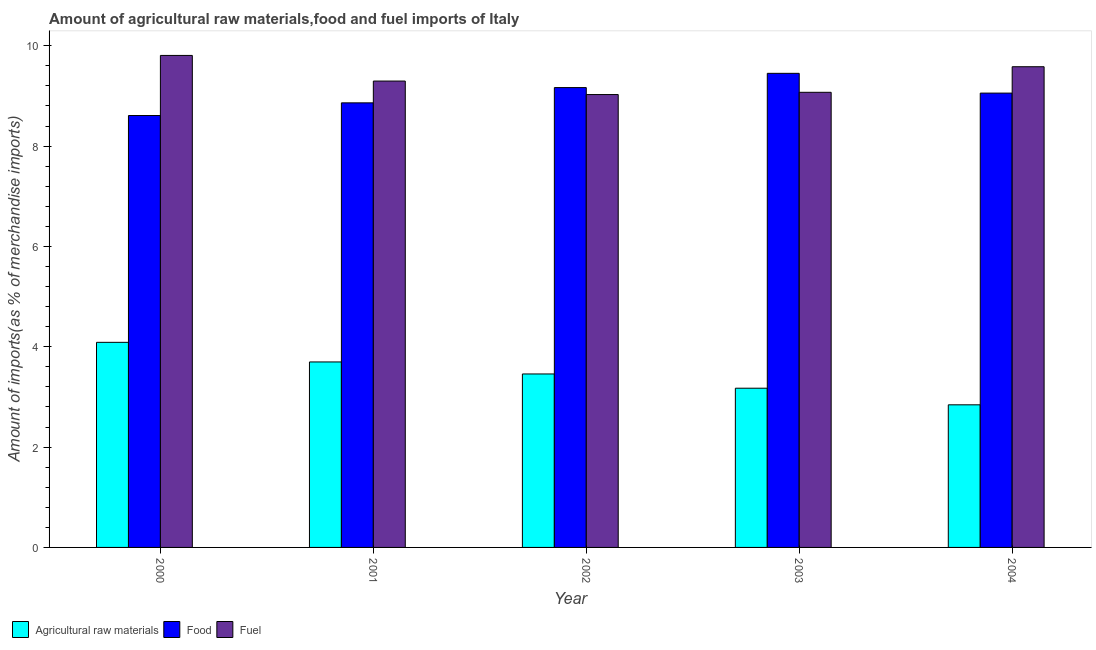How many different coloured bars are there?
Keep it short and to the point. 3. Are the number of bars on each tick of the X-axis equal?
Offer a very short reply. Yes. In how many cases, is the number of bars for a given year not equal to the number of legend labels?
Your answer should be very brief. 0. What is the percentage of raw materials imports in 2001?
Make the answer very short. 3.7. Across all years, what is the maximum percentage of food imports?
Offer a terse response. 9.45. Across all years, what is the minimum percentage of fuel imports?
Your response must be concise. 9.03. In which year was the percentage of fuel imports maximum?
Ensure brevity in your answer.  2000. What is the total percentage of food imports in the graph?
Your answer should be very brief. 45.15. What is the difference between the percentage of food imports in 2000 and that in 2002?
Keep it short and to the point. -0.56. What is the difference between the percentage of food imports in 2003 and the percentage of raw materials imports in 2001?
Make the answer very short. 0.59. What is the average percentage of fuel imports per year?
Offer a very short reply. 9.36. In how many years, is the percentage of raw materials imports greater than 9.2 %?
Provide a short and direct response. 0. What is the ratio of the percentage of raw materials imports in 2002 to that in 2003?
Provide a succinct answer. 1.09. Is the percentage of raw materials imports in 2001 less than that in 2004?
Provide a succinct answer. No. Is the difference between the percentage of raw materials imports in 2000 and 2003 greater than the difference between the percentage of fuel imports in 2000 and 2003?
Provide a succinct answer. No. What is the difference between the highest and the second highest percentage of fuel imports?
Your answer should be very brief. 0.23. What is the difference between the highest and the lowest percentage of raw materials imports?
Ensure brevity in your answer.  1.25. What does the 3rd bar from the left in 2003 represents?
Provide a succinct answer. Fuel. What does the 1st bar from the right in 2004 represents?
Your answer should be very brief. Fuel. How many years are there in the graph?
Provide a short and direct response. 5. What is the difference between two consecutive major ticks on the Y-axis?
Keep it short and to the point. 2. Does the graph contain any zero values?
Offer a very short reply. No. Where does the legend appear in the graph?
Provide a succinct answer. Bottom left. How many legend labels are there?
Keep it short and to the point. 3. What is the title of the graph?
Offer a terse response. Amount of agricultural raw materials,food and fuel imports of Italy. What is the label or title of the X-axis?
Keep it short and to the point. Year. What is the label or title of the Y-axis?
Offer a terse response. Amount of imports(as % of merchandise imports). What is the Amount of imports(as % of merchandise imports) of Agricultural raw materials in 2000?
Your answer should be compact. 4.09. What is the Amount of imports(as % of merchandise imports) of Food in 2000?
Provide a short and direct response. 8.61. What is the Amount of imports(as % of merchandise imports) in Fuel in 2000?
Your answer should be very brief. 9.81. What is the Amount of imports(as % of merchandise imports) in Agricultural raw materials in 2001?
Ensure brevity in your answer.  3.7. What is the Amount of imports(as % of merchandise imports) in Food in 2001?
Ensure brevity in your answer.  8.86. What is the Amount of imports(as % of merchandise imports) of Fuel in 2001?
Your response must be concise. 9.3. What is the Amount of imports(as % of merchandise imports) of Agricultural raw materials in 2002?
Make the answer very short. 3.46. What is the Amount of imports(as % of merchandise imports) in Food in 2002?
Provide a short and direct response. 9.17. What is the Amount of imports(as % of merchandise imports) in Fuel in 2002?
Your answer should be compact. 9.03. What is the Amount of imports(as % of merchandise imports) of Agricultural raw materials in 2003?
Keep it short and to the point. 3.17. What is the Amount of imports(as % of merchandise imports) of Food in 2003?
Offer a very short reply. 9.45. What is the Amount of imports(as % of merchandise imports) in Fuel in 2003?
Ensure brevity in your answer.  9.07. What is the Amount of imports(as % of merchandise imports) of Agricultural raw materials in 2004?
Ensure brevity in your answer.  2.84. What is the Amount of imports(as % of merchandise imports) of Food in 2004?
Give a very brief answer. 9.06. What is the Amount of imports(as % of merchandise imports) in Fuel in 2004?
Your answer should be compact. 9.58. Across all years, what is the maximum Amount of imports(as % of merchandise imports) in Agricultural raw materials?
Your response must be concise. 4.09. Across all years, what is the maximum Amount of imports(as % of merchandise imports) in Food?
Offer a very short reply. 9.45. Across all years, what is the maximum Amount of imports(as % of merchandise imports) of Fuel?
Provide a succinct answer. 9.81. Across all years, what is the minimum Amount of imports(as % of merchandise imports) in Agricultural raw materials?
Your answer should be very brief. 2.84. Across all years, what is the minimum Amount of imports(as % of merchandise imports) of Food?
Offer a very short reply. 8.61. Across all years, what is the minimum Amount of imports(as % of merchandise imports) in Fuel?
Provide a short and direct response. 9.03. What is the total Amount of imports(as % of merchandise imports) in Agricultural raw materials in the graph?
Your response must be concise. 17.26. What is the total Amount of imports(as % of merchandise imports) in Food in the graph?
Your response must be concise. 45.15. What is the total Amount of imports(as % of merchandise imports) in Fuel in the graph?
Ensure brevity in your answer.  46.79. What is the difference between the Amount of imports(as % of merchandise imports) in Agricultural raw materials in 2000 and that in 2001?
Your answer should be very brief. 0.39. What is the difference between the Amount of imports(as % of merchandise imports) of Food in 2000 and that in 2001?
Your answer should be compact. -0.25. What is the difference between the Amount of imports(as % of merchandise imports) of Fuel in 2000 and that in 2001?
Your answer should be compact. 0.51. What is the difference between the Amount of imports(as % of merchandise imports) in Agricultural raw materials in 2000 and that in 2002?
Your response must be concise. 0.63. What is the difference between the Amount of imports(as % of merchandise imports) of Food in 2000 and that in 2002?
Provide a succinct answer. -0.56. What is the difference between the Amount of imports(as % of merchandise imports) in Fuel in 2000 and that in 2002?
Your response must be concise. 0.78. What is the difference between the Amount of imports(as % of merchandise imports) in Agricultural raw materials in 2000 and that in 2003?
Give a very brief answer. 0.91. What is the difference between the Amount of imports(as % of merchandise imports) in Food in 2000 and that in 2003?
Your answer should be compact. -0.84. What is the difference between the Amount of imports(as % of merchandise imports) of Fuel in 2000 and that in 2003?
Offer a very short reply. 0.74. What is the difference between the Amount of imports(as % of merchandise imports) in Agricultural raw materials in 2000 and that in 2004?
Make the answer very short. 1.25. What is the difference between the Amount of imports(as % of merchandise imports) in Food in 2000 and that in 2004?
Your response must be concise. -0.45. What is the difference between the Amount of imports(as % of merchandise imports) in Fuel in 2000 and that in 2004?
Your answer should be very brief. 0.23. What is the difference between the Amount of imports(as % of merchandise imports) of Agricultural raw materials in 2001 and that in 2002?
Ensure brevity in your answer.  0.24. What is the difference between the Amount of imports(as % of merchandise imports) in Food in 2001 and that in 2002?
Your answer should be very brief. -0.3. What is the difference between the Amount of imports(as % of merchandise imports) of Fuel in 2001 and that in 2002?
Provide a succinct answer. 0.27. What is the difference between the Amount of imports(as % of merchandise imports) of Agricultural raw materials in 2001 and that in 2003?
Keep it short and to the point. 0.52. What is the difference between the Amount of imports(as % of merchandise imports) of Food in 2001 and that in 2003?
Your answer should be very brief. -0.59. What is the difference between the Amount of imports(as % of merchandise imports) of Fuel in 2001 and that in 2003?
Offer a terse response. 0.22. What is the difference between the Amount of imports(as % of merchandise imports) in Agricultural raw materials in 2001 and that in 2004?
Your answer should be compact. 0.85. What is the difference between the Amount of imports(as % of merchandise imports) of Food in 2001 and that in 2004?
Your answer should be compact. -0.19. What is the difference between the Amount of imports(as % of merchandise imports) of Fuel in 2001 and that in 2004?
Keep it short and to the point. -0.29. What is the difference between the Amount of imports(as % of merchandise imports) of Agricultural raw materials in 2002 and that in 2003?
Offer a very short reply. 0.28. What is the difference between the Amount of imports(as % of merchandise imports) of Food in 2002 and that in 2003?
Your response must be concise. -0.28. What is the difference between the Amount of imports(as % of merchandise imports) of Fuel in 2002 and that in 2003?
Give a very brief answer. -0.04. What is the difference between the Amount of imports(as % of merchandise imports) in Agricultural raw materials in 2002 and that in 2004?
Your response must be concise. 0.62. What is the difference between the Amount of imports(as % of merchandise imports) of Food in 2002 and that in 2004?
Ensure brevity in your answer.  0.11. What is the difference between the Amount of imports(as % of merchandise imports) of Fuel in 2002 and that in 2004?
Your answer should be very brief. -0.55. What is the difference between the Amount of imports(as % of merchandise imports) in Agricultural raw materials in 2003 and that in 2004?
Keep it short and to the point. 0.33. What is the difference between the Amount of imports(as % of merchandise imports) in Food in 2003 and that in 2004?
Offer a terse response. 0.39. What is the difference between the Amount of imports(as % of merchandise imports) in Fuel in 2003 and that in 2004?
Keep it short and to the point. -0.51. What is the difference between the Amount of imports(as % of merchandise imports) in Agricultural raw materials in 2000 and the Amount of imports(as % of merchandise imports) in Food in 2001?
Provide a short and direct response. -4.77. What is the difference between the Amount of imports(as % of merchandise imports) in Agricultural raw materials in 2000 and the Amount of imports(as % of merchandise imports) in Fuel in 2001?
Offer a terse response. -5.21. What is the difference between the Amount of imports(as % of merchandise imports) in Food in 2000 and the Amount of imports(as % of merchandise imports) in Fuel in 2001?
Your answer should be very brief. -0.69. What is the difference between the Amount of imports(as % of merchandise imports) of Agricultural raw materials in 2000 and the Amount of imports(as % of merchandise imports) of Food in 2002?
Ensure brevity in your answer.  -5.08. What is the difference between the Amount of imports(as % of merchandise imports) in Agricultural raw materials in 2000 and the Amount of imports(as % of merchandise imports) in Fuel in 2002?
Your answer should be very brief. -4.94. What is the difference between the Amount of imports(as % of merchandise imports) in Food in 2000 and the Amount of imports(as % of merchandise imports) in Fuel in 2002?
Your answer should be compact. -0.42. What is the difference between the Amount of imports(as % of merchandise imports) in Agricultural raw materials in 2000 and the Amount of imports(as % of merchandise imports) in Food in 2003?
Your response must be concise. -5.36. What is the difference between the Amount of imports(as % of merchandise imports) in Agricultural raw materials in 2000 and the Amount of imports(as % of merchandise imports) in Fuel in 2003?
Your response must be concise. -4.98. What is the difference between the Amount of imports(as % of merchandise imports) of Food in 2000 and the Amount of imports(as % of merchandise imports) of Fuel in 2003?
Give a very brief answer. -0.46. What is the difference between the Amount of imports(as % of merchandise imports) in Agricultural raw materials in 2000 and the Amount of imports(as % of merchandise imports) in Food in 2004?
Your answer should be compact. -4.97. What is the difference between the Amount of imports(as % of merchandise imports) of Agricultural raw materials in 2000 and the Amount of imports(as % of merchandise imports) of Fuel in 2004?
Your response must be concise. -5.49. What is the difference between the Amount of imports(as % of merchandise imports) in Food in 2000 and the Amount of imports(as % of merchandise imports) in Fuel in 2004?
Make the answer very short. -0.97. What is the difference between the Amount of imports(as % of merchandise imports) in Agricultural raw materials in 2001 and the Amount of imports(as % of merchandise imports) in Food in 2002?
Provide a succinct answer. -5.47. What is the difference between the Amount of imports(as % of merchandise imports) of Agricultural raw materials in 2001 and the Amount of imports(as % of merchandise imports) of Fuel in 2002?
Offer a terse response. -5.33. What is the difference between the Amount of imports(as % of merchandise imports) of Food in 2001 and the Amount of imports(as % of merchandise imports) of Fuel in 2002?
Keep it short and to the point. -0.17. What is the difference between the Amount of imports(as % of merchandise imports) of Agricultural raw materials in 2001 and the Amount of imports(as % of merchandise imports) of Food in 2003?
Ensure brevity in your answer.  -5.75. What is the difference between the Amount of imports(as % of merchandise imports) in Agricultural raw materials in 2001 and the Amount of imports(as % of merchandise imports) in Fuel in 2003?
Keep it short and to the point. -5.38. What is the difference between the Amount of imports(as % of merchandise imports) in Food in 2001 and the Amount of imports(as % of merchandise imports) in Fuel in 2003?
Provide a succinct answer. -0.21. What is the difference between the Amount of imports(as % of merchandise imports) in Agricultural raw materials in 2001 and the Amount of imports(as % of merchandise imports) in Food in 2004?
Offer a terse response. -5.36. What is the difference between the Amount of imports(as % of merchandise imports) of Agricultural raw materials in 2001 and the Amount of imports(as % of merchandise imports) of Fuel in 2004?
Keep it short and to the point. -5.89. What is the difference between the Amount of imports(as % of merchandise imports) in Food in 2001 and the Amount of imports(as % of merchandise imports) in Fuel in 2004?
Provide a short and direct response. -0.72. What is the difference between the Amount of imports(as % of merchandise imports) in Agricultural raw materials in 2002 and the Amount of imports(as % of merchandise imports) in Food in 2003?
Make the answer very short. -5.99. What is the difference between the Amount of imports(as % of merchandise imports) in Agricultural raw materials in 2002 and the Amount of imports(as % of merchandise imports) in Fuel in 2003?
Your answer should be very brief. -5.62. What is the difference between the Amount of imports(as % of merchandise imports) in Food in 2002 and the Amount of imports(as % of merchandise imports) in Fuel in 2003?
Offer a terse response. 0.09. What is the difference between the Amount of imports(as % of merchandise imports) in Agricultural raw materials in 2002 and the Amount of imports(as % of merchandise imports) in Food in 2004?
Ensure brevity in your answer.  -5.6. What is the difference between the Amount of imports(as % of merchandise imports) in Agricultural raw materials in 2002 and the Amount of imports(as % of merchandise imports) in Fuel in 2004?
Give a very brief answer. -6.12. What is the difference between the Amount of imports(as % of merchandise imports) of Food in 2002 and the Amount of imports(as % of merchandise imports) of Fuel in 2004?
Offer a very short reply. -0.42. What is the difference between the Amount of imports(as % of merchandise imports) of Agricultural raw materials in 2003 and the Amount of imports(as % of merchandise imports) of Food in 2004?
Your answer should be compact. -5.88. What is the difference between the Amount of imports(as % of merchandise imports) in Agricultural raw materials in 2003 and the Amount of imports(as % of merchandise imports) in Fuel in 2004?
Offer a terse response. -6.41. What is the difference between the Amount of imports(as % of merchandise imports) in Food in 2003 and the Amount of imports(as % of merchandise imports) in Fuel in 2004?
Give a very brief answer. -0.13. What is the average Amount of imports(as % of merchandise imports) in Agricultural raw materials per year?
Your answer should be very brief. 3.45. What is the average Amount of imports(as % of merchandise imports) in Food per year?
Keep it short and to the point. 9.03. What is the average Amount of imports(as % of merchandise imports) of Fuel per year?
Give a very brief answer. 9.36. In the year 2000, what is the difference between the Amount of imports(as % of merchandise imports) in Agricultural raw materials and Amount of imports(as % of merchandise imports) in Food?
Give a very brief answer. -4.52. In the year 2000, what is the difference between the Amount of imports(as % of merchandise imports) in Agricultural raw materials and Amount of imports(as % of merchandise imports) in Fuel?
Your response must be concise. -5.72. In the year 2000, what is the difference between the Amount of imports(as % of merchandise imports) of Food and Amount of imports(as % of merchandise imports) of Fuel?
Provide a succinct answer. -1.2. In the year 2001, what is the difference between the Amount of imports(as % of merchandise imports) of Agricultural raw materials and Amount of imports(as % of merchandise imports) of Food?
Offer a very short reply. -5.17. In the year 2001, what is the difference between the Amount of imports(as % of merchandise imports) of Agricultural raw materials and Amount of imports(as % of merchandise imports) of Fuel?
Offer a terse response. -5.6. In the year 2001, what is the difference between the Amount of imports(as % of merchandise imports) of Food and Amount of imports(as % of merchandise imports) of Fuel?
Provide a succinct answer. -0.43. In the year 2002, what is the difference between the Amount of imports(as % of merchandise imports) in Agricultural raw materials and Amount of imports(as % of merchandise imports) in Food?
Keep it short and to the point. -5.71. In the year 2002, what is the difference between the Amount of imports(as % of merchandise imports) of Agricultural raw materials and Amount of imports(as % of merchandise imports) of Fuel?
Keep it short and to the point. -5.57. In the year 2002, what is the difference between the Amount of imports(as % of merchandise imports) of Food and Amount of imports(as % of merchandise imports) of Fuel?
Offer a terse response. 0.14. In the year 2003, what is the difference between the Amount of imports(as % of merchandise imports) of Agricultural raw materials and Amount of imports(as % of merchandise imports) of Food?
Give a very brief answer. -6.28. In the year 2003, what is the difference between the Amount of imports(as % of merchandise imports) in Agricultural raw materials and Amount of imports(as % of merchandise imports) in Fuel?
Offer a very short reply. -5.9. In the year 2003, what is the difference between the Amount of imports(as % of merchandise imports) in Food and Amount of imports(as % of merchandise imports) in Fuel?
Offer a terse response. 0.38. In the year 2004, what is the difference between the Amount of imports(as % of merchandise imports) in Agricultural raw materials and Amount of imports(as % of merchandise imports) in Food?
Your answer should be very brief. -6.21. In the year 2004, what is the difference between the Amount of imports(as % of merchandise imports) of Agricultural raw materials and Amount of imports(as % of merchandise imports) of Fuel?
Your answer should be very brief. -6.74. In the year 2004, what is the difference between the Amount of imports(as % of merchandise imports) of Food and Amount of imports(as % of merchandise imports) of Fuel?
Make the answer very short. -0.53. What is the ratio of the Amount of imports(as % of merchandise imports) of Agricultural raw materials in 2000 to that in 2001?
Make the answer very short. 1.11. What is the ratio of the Amount of imports(as % of merchandise imports) in Food in 2000 to that in 2001?
Offer a very short reply. 0.97. What is the ratio of the Amount of imports(as % of merchandise imports) in Fuel in 2000 to that in 2001?
Ensure brevity in your answer.  1.05. What is the ratio of the Amount of imports(as % of merchandise imports) in Agricultural raw materials in 2000 to that in 2002?
Ensure brevity in your answer.  1.18. What is the ratio of the Amount of imports(as % of merchandise imports) of Food in 2000 to that in 2002?
Make the answer very short. 0.94. What is the ratio of the Amount of imports(as % of merchandise imports) of Fuel in 2000 to that in 2002?
Keep it short and to the point. 1.09. What is the ratio of the Amount of imports(as % of merchandise imports) in Agricultural raw materials in 2000 to that in 2003?
Keep it short and to the point. 1.29. What is the ratio of the Amount of imports(as % of merchandise imports) in Food in 2000 to that in 2003?
Provide a short and direct response. 0.91. What is the ratio of the Amount of imports(as % of merchandise imports) in Fuel in 2000 to that in 2003?
Your response must be concise. 1.08. What is the ratio of the Amount of imports(as % of merchandise imports) in Agricultural raw materials in 2000 to that in 2004?
Your answer should be very brief. 1.44. What is the ratio of the Amount of imports(as % of merchandise imports) of Food in 2000 to that in 2004?
Provide a succinct answer. 0.95. What is the ratio of the Amount of imports(as % of merchandise imports) in Fuel in 2000 to that in 2004?
Keep it short and to the point. 1.02. What is the ratio of the Amount of imports(as % of merchandise imports) of Agricultural raw materials in 2001 to that in 2002?
Give a very brief answer. 1.07. What is the ratio of the Amount of imports(as % of merchandise imports) in Food in 2001 to that in 2002?
Provide a succinct answer. 0.97. What is the ratio of the Amount of imports(as % of merchandise imports) in Fuel in 2001 to that in 2002?
Your answer should be compact. 1.03. What is the ratio of the Amount of imports(as % of merchandise imports) of Agricultural raw materials in 2001 to that in 2003?
Offer a very short reply. 1.16. What is the ratio of the Amount of imports(as % of merchandise imports) of Food in 2001 to that in 2003?
Your response must be concise. 0.94. What is the ratio of the Amount of imports(as % of merchandise imports) in Fuel in 2001 to that in 2003?
Provide a succinct answer. 1.02. What is the ratio of the Amount of imports(as % of merchandise imports) in Agricultural raw materials in 2001 to that in 2004?
Give a very brief answer. 1.3. What is the ratio of the Amount of imports(as % of merchandise imports) in Food in 2001 to that in 2004?
Make the answer very short. 0.98. What is the ratio of the Amount of imports(as % of merchandise imports) in Fuel in 2001 to that in 2004?
Your answer should be very brief. 0.97. What is the ratio of the Amount of imports(as % of merchandise imports) in Agricultural raw materials in 2002 to that in 2003?
Give a very brief answer. 1.09. What is the ratio of the Amount of imports(as % of merchandise imports) of Food in 2002 to that in 2003?
Your answer should be compact. 0.97. What is the ratio of the Amount of imports(as % of merchandise imports) in Fuel in 2002 to that in 2003?
Ensure brevity in your answer.  1. What is the ratio of the Amount of imports(as % of merchandise imports) in Agricultural raw materials in 2002 to that in 2004?
Make the answer very short. 1.22. What is the ratio of the Amount of imports(as % of merchandise imports) in Food in 2002 to that in 2004?
Give a very brief answer. 1.01. What is the ratio of the Amount of imports(as % of merchandise imports) in Fuel in 2002 to that in 2004?
Make the answer very short. 0.94. What is the ratio of the Amount of imports(as % of merchandise imports) in Agricultural raw materials in 2003 to that in 2004?
Offer a very short reply. 1.12. What is the ratio of the Amount of imports(as % of merchandise imports) of Food in 2003 to that in 2004?
Your answer should be compact. 1.04. What is the ratio of the Amount of imports(as % of merchandise imports) of Fuel in 2003 to that in 2004?
Your response must be concise. 0.95. What is the difference between the highest and the second highest Amount of imports(as % of merchandise imports) in Agricultural raw materials?
Offer a very short reply. 0.39. What is the difference between the highest and the second highest Amount of imports(as % of merchandise imports) of Food?
Your answer should be compact. 0.28. What is the difference between the highest and the second highest Amount of imports(as % of merchandise imports) in Fuel?
Give a very brief answer. 0.23. What is the difference between the highest and the lowest Amount of imports(as % of merchandise imports) in Agricultural raw materials?
Provide a short and direct response. 1.25. What is the difference between the highest and the lowest Amount of imports(as % of merchandise imports) of Food?
Give a very brief answer. 0.84. What is the difference between the highest and the lowest Amount of imports(as % of merchandise imports) of Fuel?
Your answer should be compact. 0.78. 